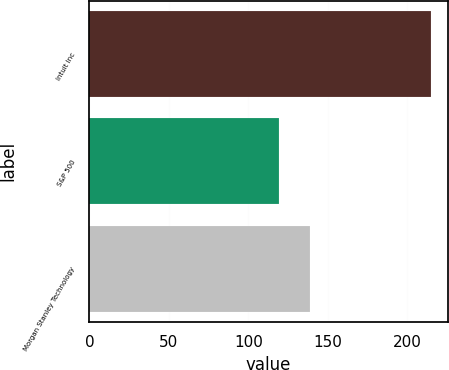Convert chart. <chart><loc_0><loc_0><loc_500><loc_500><bar_chart><fcel>Intuit Inc<fcel>S&P 500<fcel>Morgan Stanley Technology<nl><fcel>214.66<fcel>118.97<fcel>138.98<nl></chart> 